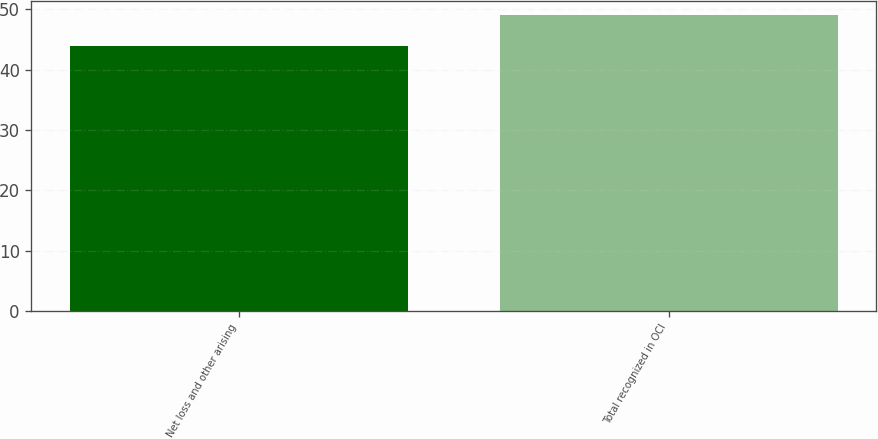<chart> <loc_0><loc_0><loc_500><loc_500><bar_chart><fcel>Net loss and other arising<fcel>Total recognized in OCI<nl><fcel>44<fcel>49<nl></chart> 